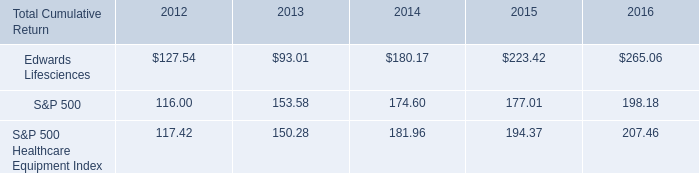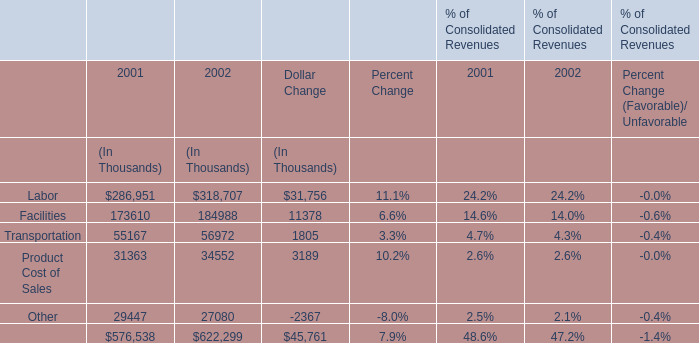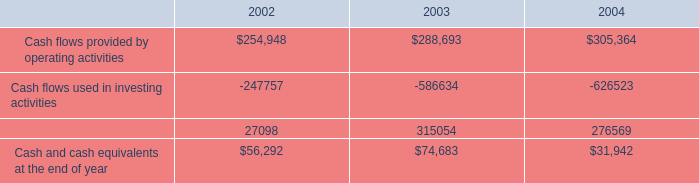What's the growth rate of Facilities's percent of Consolidated Revenues in 2002? 
Computations: ((14.0 - 14.6) / 14.6)
Answer: -0.0411. 